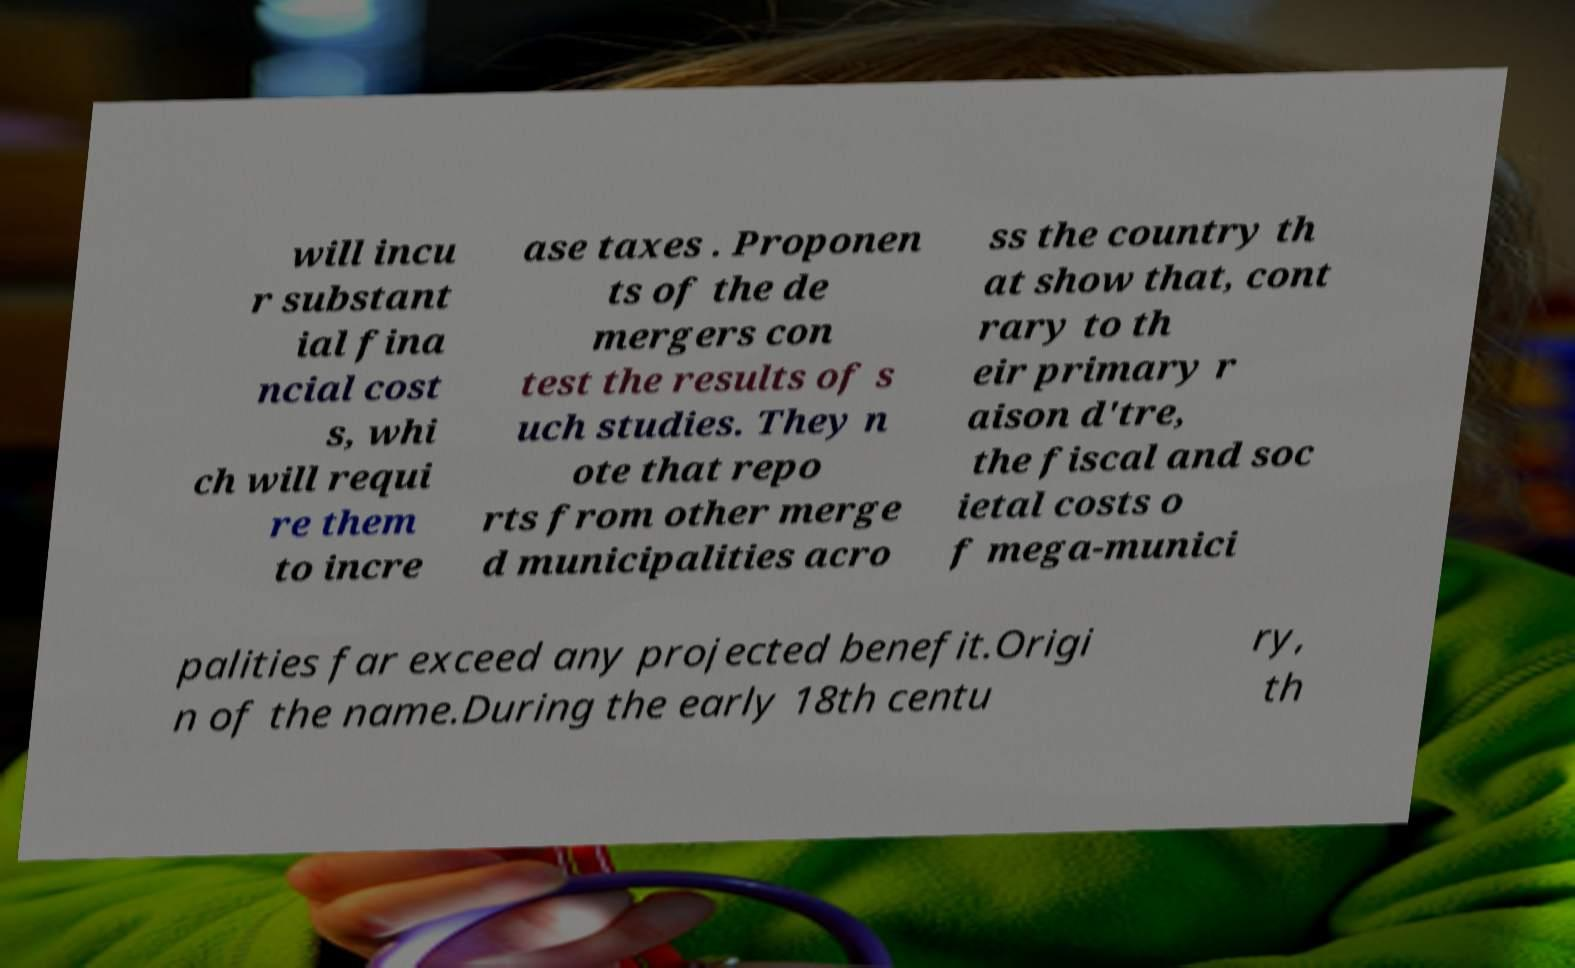There's text embedded in this image that I need extracted. Can you transcribe it verbatim? will incu r substant ial fina ncial cost s, whi ch will requi re them to incre ase taxes . Proponen ts of the de mergers con test the results of s uch studies. They n ote that repo rts from other merge d municipalities acro ss the country th at show that, cont rary to th eir primary r aison d'tre, the fiscal and soc ietal costs o f mega-munici palities far exceed any projected benefit.Origi n of the name.During the early 18th centu ry, th 